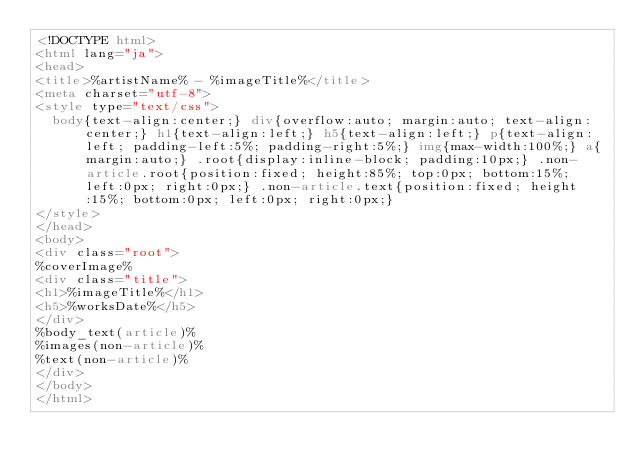<code> <loc_0><loc_0><loc_500><loc_500><_HTML_><!DOCTYPE html>
<html lang="ja">
<head>
<title>%artistName% - %imageTitle%</title>
<meta charset="utf-8">
<style type="text/css">
  body{text-align:center;} div{overflow:auto; margin:auto; text-align:center;} h1{text-align:left;} h5{text-align:left;} p{text-align:left; padding-left:5%; padding-right:5%;} img{max-width:100%;} a{margin:auto;} .root{display:inline-block; padding:10px;} .non-article.root{position:fixed; height:85%; top:0px; bottom:15%; left:0px; right:0px;} .non-article.text{position:fixed; height:15%; bottom:0px; left:0px; right:0px;}
</style>
</head>
<body>
<div class="root">
%coverImage%
<div class="title">
<h1>%imageTitle%</h1>
<h5>%worksDate%</h5>
</div>
%body_text(article)%
%images(non-article)%
%text(non-article)%
</div>
</body>
</html>
</code> 